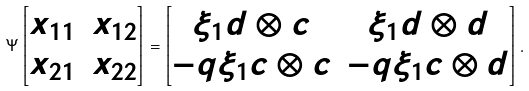Convert formula to latex. <formula><loc_0><loc_0><loc_500><loc_500>\Psi \left [ \begin{matrix} x _ { 1 1 } & x _ { 1 2 } \\ x _ { 2 1 } & x _ { 2 2 } \end{matrix} \right ] = \left [ \begin{matrix} \xi _ { 1 } d \otimes c & \xi _ { 1 } d \otimes d \\ - q \xi _ { 1 } c \otimes c & - q \xi _ { 1 } c \otimes d \end{matrix} \right ] .</formula> 